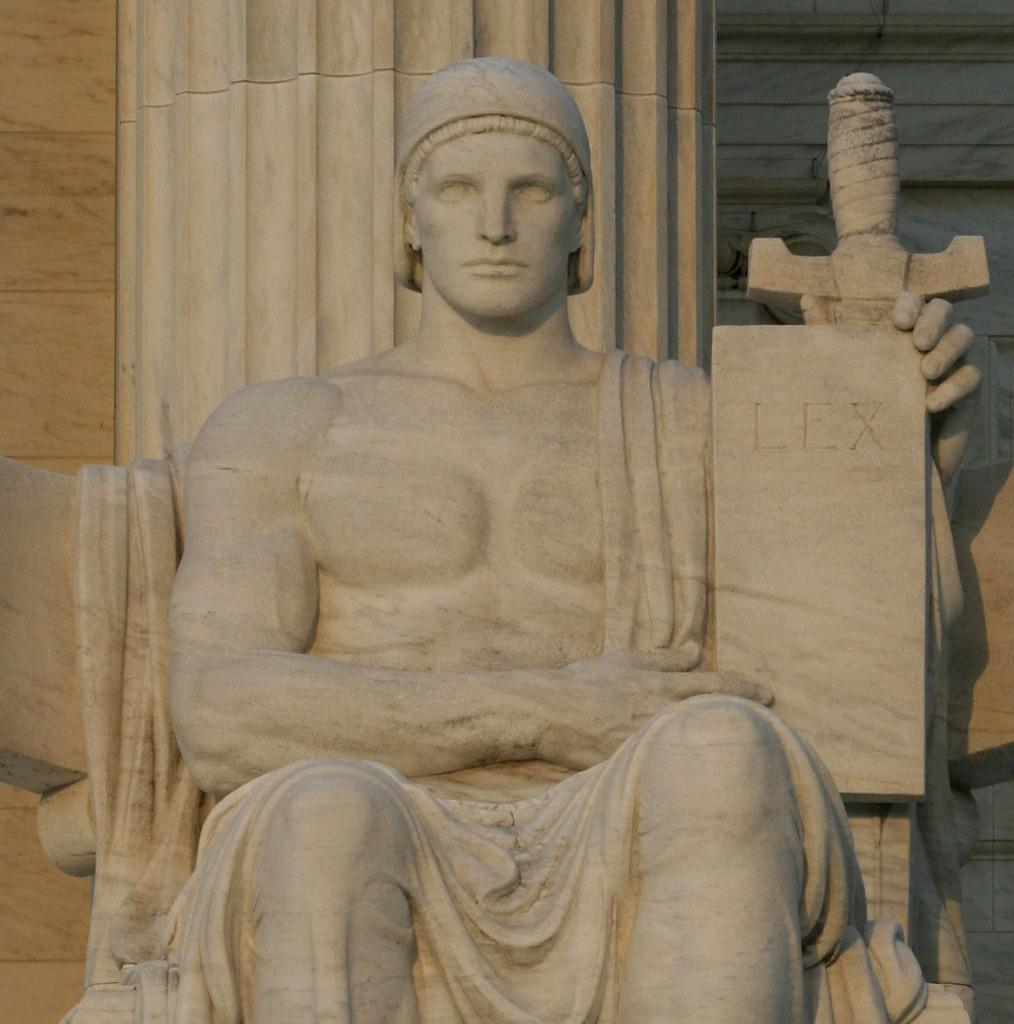What is the main subject in the center of the image? There is a statue of a person in the center of the image. What can be seen in the background of the image? There is a wall in the background of the image. Are there any bears visible in the image? No, there are no bears present in the image. Can you see a snake slithering on the wall in the background? No, there is no snake visible in the image. 